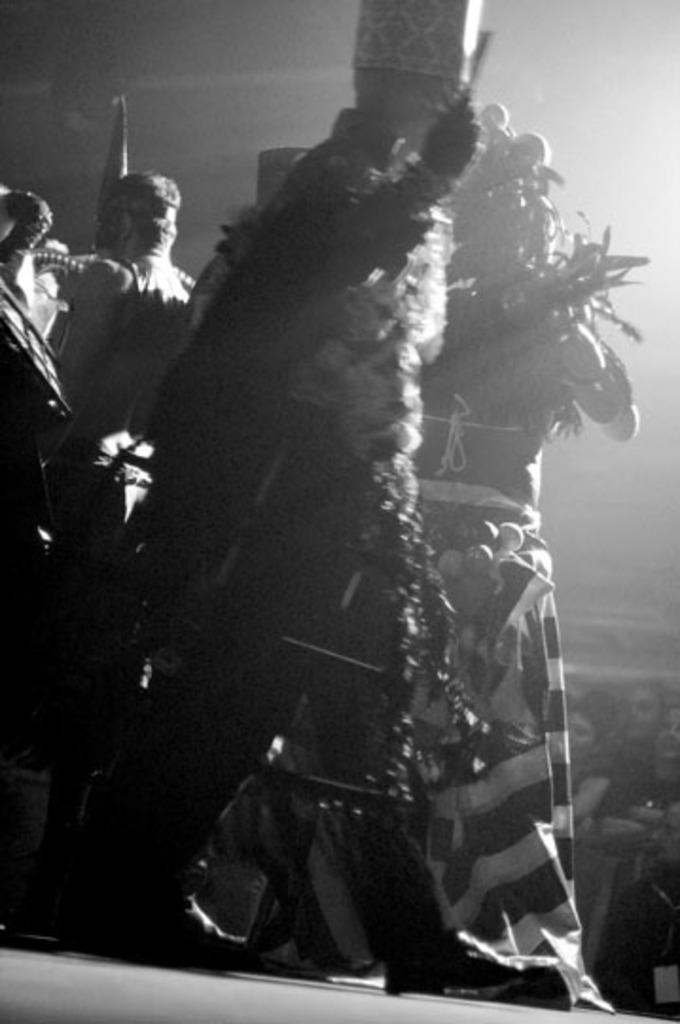What is the color scheme of the image? The image is black and white. What can be seen in the image? There are people in the image. What are the people wearing in the image? The people are wearing costumes. What type of insurance is being discussed by the people in the image? There is no discussion about insurance in the image. 